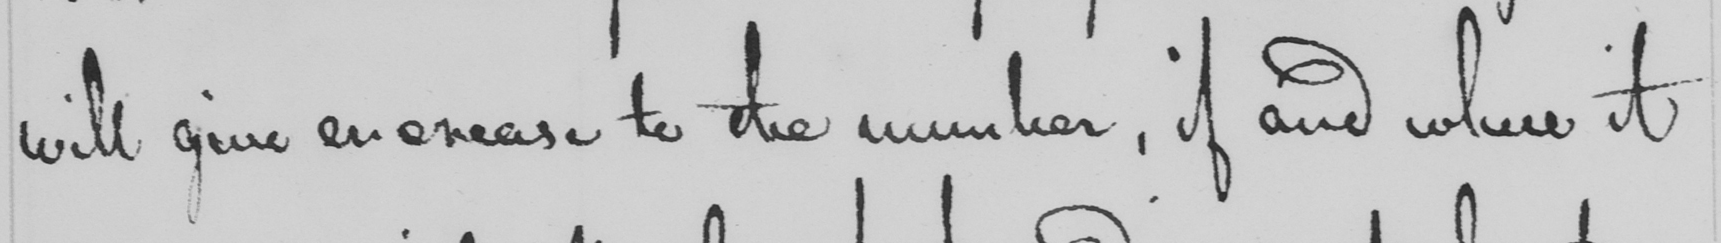What text is written in this handwritten line? will give encrease to the number , if and where it 